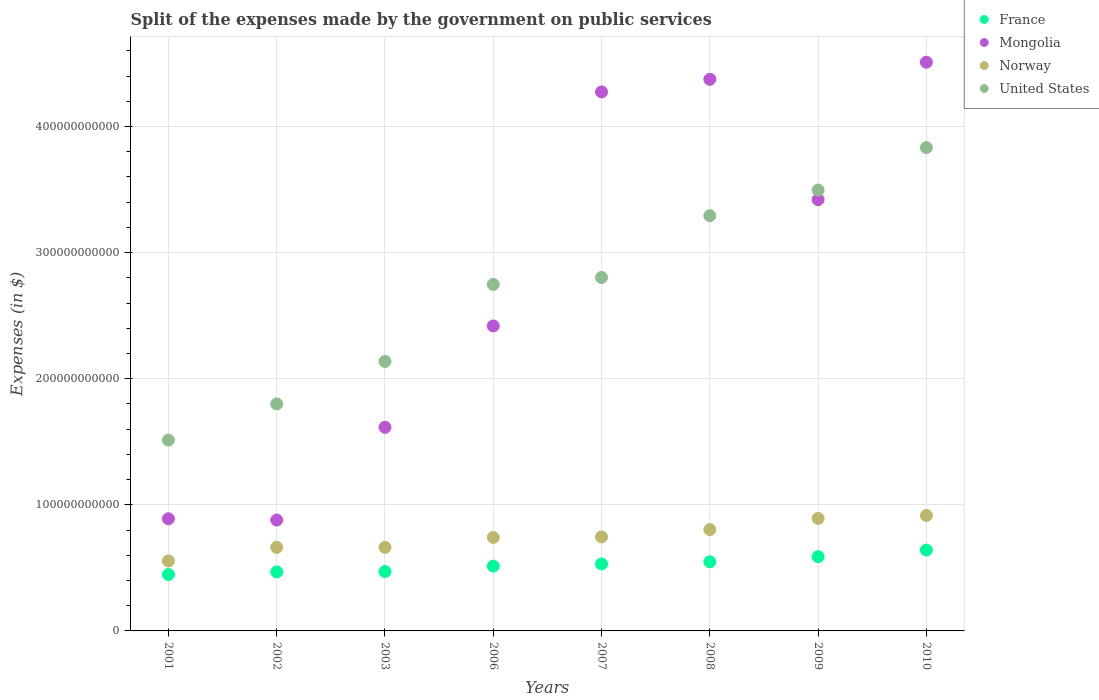What is the expenses made by the government on public services in France in 2007?
Ensure brevity in your answer.  5.31e+1. Across all years, what is the maximum expenses made by the government on public services in Norway?
Offer a very short reply. 9.15e+1. Across all years, what is the minimum expenses made by the government on public services in Norway?
Keep it short and to the point. 5.55e+1. In which year was the expenses made by the government on public services in Norway maximum?
Keep it short and to the point. 2010. What is the total expenses made by the government on public services in Mongolia in the graph?
Keep it short and to the point. 2.24e+12. What is the difference between the expenses made by the government on public services in France in 2008 and that in 2010?
Ensure brevity in your answer.  -9.30e+09. What is the difference between the expenses made by the government on public services in France in 2010 and the expenses made by the government on public services in Norway in 2009?
Keep it short and to the point. -2.51e+1. What is the average expenses made by the government on public services in France per year?
Make the answer very short. 5.26e+1. In the year 2010, what is the difference between the expenses made by the government on public services in Norway and expenses made by the government on public services in France?
Provide a succinct answer. 2.74e+1. What is the ratio of the expenses made by the government on public services in United States in 2006 to that in 2009?
Provide a succinct answer. 0.79. Is the difference between the expenses made by the government on public services in Norway in 2003 and 2007 greater than the difference between the expenses made by the government on public services in France in 2003 and 2007?
Your answer should be compact. No. What is the difference between the highest and the second highest expenses made by the government on public services in Mongolia?
Provide a short and direct response. 1.36e+1. What is the difference between the highest and the lowest expenses made by the government on public services in France?
Provide a short and direct response. 1.94e+1. Is the sum of the expenses made by the government on public services in France in 2006 and 2007 greater than the maximum expenses made by the government on public services in Norway across all years?
Keep it short and to the point. Yes. Does the expenses made by the government on public services in United States monotonically increase over the years?
Provide a succinct answer. Yes. Is the expenses made by the government on public services in Mongolia strictly less than the expenses made by the government on public services in France over the years?
Keep it short and to the point. No. How many dotlines are there?
Give a very brief answer. 4. What is the difference between two consecutive major ticks on the Y-axis?
Offer a very short reply. 1.00e+11. Does the graph contain any zero values?
Ensure brevity in your answer.  No. Does the graph contain grids?
Your response must be concise. Yes. Where does the legend appear in the graph?
Keep it short and to the point. Top right. How many legend labels are there?
Your answer should be very brief. 4. What is the title of the graph?
Your answer should be very brief. Split of the expenses made by the government on public services. Does "Zimbabwe" appear as one of the legend labels in the graph?
Your response must be concise. No. What is the label or title of the Y-axis?
Provide a short and direct response. Expenses (in $). What is the Expenses (in $) of France in 2001?
Make the answer very short. 4.47e+1. What is the Expenses (in $) in Mongolia in 2001?
Give a very brief answer. 8.89e+1. What is the Expenses (in $) of Norway in 2001?
Keep it short and to the point. 5.55e+1. What is the Expenses (in $) in United States in 2001?
Your answer should be compact. 1.51e+11. What is the Expenses (in $) in France in 2002?
Give a very brief answer. 4.68e+1. What is the Expenses (in $) in Mongolia in 2002?
Keep it short and to the point. 8.79e+1. What is the Expenses (in $) of Norway in 2002?
Make the answer very short. 6.63e+1. What is the Expenses (in $) in United States in 2002?
Provide a short and direct response. 1.80e+11. What is the Expenses (in $) in France in 2003?
Give a very brief answer. 4.71e+1. What is the Expenses (in $) in Mongolia in 2003?
Your answer should be very brief. 1.61e+11. What is the Expenses (in $) of Norway in 2003?
Your answer should be very brief. 6.63e+1. What is the Expenses (in $) in United States in 2003?
Your answer should be compact. 2.14e+11. What is the Expenses (in $) in France in 2006?
Keep it short and to the point. 5.14e+1. What is the Expenses (in $) in Mongolia in 2006?
Provide a short and direct response. 2.42e+11. What is the Expenses (in $) in Norway in 2006?
Offer a very short reply. 7.42e+1. What is the Expenses (in $) in United States in 2006?
Make the answer very short. 2.75e+11. What is the Expenses (in $) of France in 2007?
Your answer should be compact. 5.31e+1. What is the Expenses (in $) in Mongolia in 2007?
Ensure brevity in your answer.  4.27e+11. What is the Expenses (in $) of Norway in 2007?
Your answer should be very brief. 7.46e+1. What is the Expenses (in $) in United States in 2007?
Provide a short and direct response. 2.80e+11. What is the Expenses (in $) of France in 2008?
Your answer should be very brief. 5.48e+1. What is the Expenses (in $) of Mongolia in 2008?
Give a very brief answer. 4.37e+11. What is the Expenses (in $) in Norway in 2008?
Provide a short and direct response. 8.04e+1. What is the Expenses (in $) of United States in 2008?
Your answer should be very brief. 3.29e+11. What is the Expenses (in $) in France in 2009?
Your answer should be very brief. 5.89e+1. What is the Expenses (in $) of Mongolia in 2009?
Keep it short and to the point. 3.42e+11. What is the Expenses (in $) in Norway in 2009?
Offer a terse response. 8.92e+1. What is the Expenses (in $) in United States in 2009?
Provide a succinct answer. 3.50e+11. What is the Expenses (in $) in France in 2010?
Make the answer very short. 6.41e+1. What is the Expenses (in $) of Mongolia in 2010?
Keep it short and to the point. 4.51e+11. What is the Expenses (in $) in Norway in 2010?
Provide a succinct answer. 9.15e+1. What is the Expenses (in $) of United States in 2010?
Offer a very short reply. 3.83e+11. Across all years, what is the maximum Expenses (in $) in France?
Your response must be concise. 6.41e+1. Across all years, what is the maximum Expenses (in $) of Mongolia?
Keep it short and to the point. 4.51e+11. Across all years, what is the maximum Expenses (in $) in Norway?
Offer a very short reply. 9.15e+1. Across all years, what is the maximum Expenses (in $) of United States?
Provide a short and direct response. 3.83e+11. Across all years, what is the minimum Expenses (in $) of France?
Offer a terse response. 4.47e+1. Across all years, what is the minimum Expenses (in $) of Mongolia?
Offer a very short reply. 8.79e+1. Across all years, what is the minimum Expenses (in $) of Norway?
Your answer should be compact. 5.55e+1. Across all years, what is the minimum Expenses (in $) in United States?
Your answer should be very brief. 1.51e+11. What is the total Expenses (in $) in France in the graph?
Your answer should be compact. 4.21e+11. What is the total Expenses (in $) of Mongolia in the graph?
Your answer should be compact. 2.24e+12. What is the total Expenses (in $) of Norway in the graph?
Your response must be concise. 5.98e+11. What is the total Expenses (in $) in United States in the graph?
Keep it short and to the point. 2.16e+12. What is the difference between the Expenses (in $) of France in 2001 and that in 2002?
Give a very brief answer. -2.07e+09. What is the difference between the Expenses (in $) of Mongolia in 2001 and that in 2002?
Offer a very short reply. 1.00e+09. What is the difference between the Expenses (in $) in Norway in 2001 and that in 2002?
Your response must be concise. -1.07e+1. What is the difference between the Expenses (in $) of United States in 2001 and that in 2002?
Keep it short and to the point. -2.87e+1. What is the difference between the Expenses (in $) of France in 2001 and that in 2003?
Your response must be concise. -2.36e+09. What is the difference between the Expenses (in $) of Mongolia in 2001 and that in 2003?
Make the answer very short. -7.25e+1. What is the difference between the Expenses (in $) of Norway in 2001 and that in 2003?
Your response must be concise. -1.08e+1. What is the difference between the Expenses (in $) in United States in 2001 and that in 2003?
Make the answer very short. -6.24e+1. What is the difference between the Expenses (in $) of France in 2001 and that in 2006?
Offer a terse response. -6.65e+09. What is the difference between the Expenses (in $) in Mongolia in 2001 and that in 2006?
Offer a very short reply. -1.53e+11. What is the difference between the Expenses (in $) of Norway in 2001 and that in 2006?
Make the answer very short. -1.86e+1. What is the difference between the Expenses (in $) in United States in 2001 and that in 2006?
Give a very brief answer. -1.24e+11. What is the difference between the Expenses (in $) in France in 2001 and that in 2007?
Offer a very short reply. -8.38e+09. What is the difference between the Expenses (in $) in Mongolia in 2001 and that in 2007?
Provide a succinct answer. -3.39e+11. What is the difference between the Expenses (in $) of Norway in 2001 and that in 2007?
Your answer should be compact. -1.91e+1. What is the difference between the Expenses (in $) of United States in 2001 and that in 2007?
Give a very brief answer. -1.29e+11. What is the difference between the Expenses (in $) in France in 2001 and that in 2008?
Keep it short and to the point. -1.01e+1. What is the difference between the Expenses (in $) of Mongolia in 2001 and that in 2008?
Your response must be concise. -3.49e+11. What is the difference between the Expenses (in $) in Norway in 2001 and that in 2008?
Ensure brevity in your answer.  -2.49e+1. What is the difference between the Expenses (in $) of United States in 2001 and that in 2008?
Provide a succinct answer. -1.78e+11. What is the difference between the Expenses (in $) in France in 2001 and that in 2009?
Offer a terse response. -1.42e+1. What is the difference between the Expenses (in $) of Mongolia in 2001 and that in 2009?
Offer a terse response. -2.53e+11. What is the difference between the Expenses (in $) in Norway in 2001 and that in 2009?
Offer a terse response. -3.37e+1. What is the difference between the Expenses (in $) of United States in 2001 and that in 2009?
Offer a very short reply. -1.98e+11. What is the difference between the Expenses (in $) in France in 2001 and that in 2010?
Offer a terse response. -1.94e+1. What is the difference between the Expenses (in $) in Mongolia in 2001 and that in 2010?
Your answer should be very brief. -3.62e+11. What is the difference between the Expenses (in $) in Norway in 2001 and that in 2010?
Keep it short and to the point. -3.60e+1. What is the difference between the Expenses (in $) of United States in 2001 and that in 2010?
Keep it short and to the point. -2.32e+11. What is the difference between the Expenses (in $) of France in 2002 and that in 2003?
Provide a short and direct response. -2.92e+08. What is the difference between the Expenses (in $) of Mongolia in 2002 and that in 2003?
Your response must be concise. -7.35e+1. What is the difference between the Expenses (in $) of Norway in 2002 and that in 2003?
Provide a short and direct response. -7.00e+06. What is the difference between the Expenses (in $) of United States in 2002 and that in 2003?
Offer a very short reply. -3.37e+1. What is the difference between the Expenses (in $) in France in 2002 and that in 2006?
Offer a very short reply. -4.58e+09. What is the difference between the Expenses (in $) of Mongolia in 2002 and that in 2006?
Provide a succinct answer. -1.54e+11. What is the difference between the Expenses (in $) of Norway in 2002 and that in 2006?
Keep it short and to the point. -7.89e+09. What is the difference between the Expenses (in $) of United States in 2002 and that in 2006?
Your response must be concise. -9.48e+1. What is the difference between the Expenses (in $) of France in 2002 and that in 2007?
Your answer should be compact. -6.31e+09. What is the difference between the Expenses (in $) of Mongolia in 2002 and that in 2007?
Offer a very short reply. -3.40e+11. What is the difference between the Expenses (in $) in Norway in 2002 and that in 2007?
Make the answer very short. -8.31e+09. What is the difference between the Expenses (in $) in United States in 2002 and that in 2007?
Your answer should be very brief. -1.00e+11. What is the difference between the Expenses (in $) in France in 2002 and that in 2008?
Your response must be concise. -7.99e+09. What is the difference between the Expenses (in $) of Mongolia in 2002 and that in 2008?
Give a very brief answer. -3.50e+11. What is the difference between the Expenses (in $) of Norway in 2002 and that in 2008?
Provide a succinct answer. -1.41e+1. What is the difference between the Expenses (in $) of United States in 2002 and that in 2008?
Provide a short and direct response. -1.49e+11. What is the difference between the Expenses (in $) in France in 2002 and that in 2009?
Your answer should be very brief. -1.21e+1. What is the difference between the Expenses (in $) in Mongolia in 2002 and that in 2009?
Provide a succinct answer. -2.54e+11. What is the difference between the Expenses (in $) in Norway in 2002 and that in 2009?
Provide a succinct answer. -2.30e+1. What is the difference between the Expenses (in $) in United States in 2002 and that in 2009?
Make the answer very short. -1.70e+11. What is the difference between the Expenses (in $) of France in 2002 and that in 2010?
Offer a very short reply. -1.73e+1. What is the difference between the Expenses (in $) of Mongolia in 2002 and that in 2010?
Give a very brief answer. -3.63e+11. What is the difference between the Expenses (in $) of Norway in 2002 and that in 2010?
Keep it short and to the point. -2.53e+1. What is the difference between the Expenses (in $) of United States in 2002 and that in 2010?
Provide a short and direct response. -2.03e+11. What is the difference between the Expenses (in $) in France in 2003 and that in 2006?
Ensure brevity in your answer.  -4.28e+09. What is the difference between the Expenses (in $) in Mongolia in 2003 and that in 2006?
Offer a very short reply. -8.04e+1. What is the difference between the Expenses (in $) of Norway in 2003 and that in 2006?
Provide a short and direct response. -7.88e+09. What is the difference between the Expenses (in $) in United States in 2003 and that in 2006?
Your answer should be compact. -6.11e+1. What is the difference between the Expenses (in $) of France in 2003 and that in 2007?
Your response must be concise. -6.01e+09. What is the difference between the Expenses (in $) of Mongolia in 2003 and that in 2007?
Your response must be concise. -2.66e+11. What is the difference between the Expenses (in $) of Norway in 2003 and that in 2007?
Offer a very short reply. -8.30e+09. What is the difference between the Expenses (in $) in United States in 2003 and that in 2007?
Ensure brevity in your answer.  -6.66e+1. What is the difference between the Expenses (in $) in France in 2003 and that in 2008?
Provide a succinct answer. -7.69e+09. What is the difference between the Expenses (in $) in Mongolia in 2003 and that in 2008?
Your response must be concise. -2.76e+11. What is the difference between the Expenses (in $) in Norway in 2003 and that in 2008?
Ensure brevity in your answer.  -1.41e+1. What is the difference between the Expenses (in $) in United States in 2003 and that in 2008?
Make the answer very short. -1.16e+11. What is the difference between the Expenses (in $) of France in 2003 and that in 2009?
Make the answer very short. -1.18e+1. What is the difference between the Expenses (in $) in Mongolia in 2003 and that in 2009?
Give a very brief answer. -1.81e+11. What is the difference between the Expenses (in $) in Norway in 2003 and that in 2009?
Provide a short and direct response. -2.30e+1. What is the difference between the Expenses (in $) in United States in 2003 and that in 2009?
Your answer should be compact. -1.36e+11. What is the difference between the Expenses (in $) in France in 2003 and that in 2010?
Make the answer very short. -1.70e+1. What is the difference between the Expenses (in $) in Mongolia in 2003 and that in 2010?
Your answer should be compact. -2.90e+11. What is the difference between the Expenses (in $) in Norway in 2003 and that in 2010?
Ensure brevity in your answer.  -2.53e+1. What is the difference between the Expenses (in $) in United States in 2003 and that in 2010?
Give a very brief answer. -1.70e+11. What is the difference between the Expenses (in $) in France in 2006 and that in 2007?
Your answer should be compact. -1.73e+09. What is the difference between the Expenses (in $) of Mongolia in 2006 and that in 2007?
Keep it short and to the point. -1.86e+11. What is the difference between the Expenses (in $) of Norway in 2006 and that in 2007?
Provide a short and direct response. -4.20e+08. What is the difference between the Expenses (in $) of United States in 2006 and that in 2007?
Give a very brief answer. -5.50e+09. What is the difference between the Expenses (in $) of France in 2006 and that in 2008?
Ensure brevity in your answer.  -3.41e+09. What is the difference between the Expenses (in $) in Mongolia in 2006 and that in 2008?
Provide a succinct answer. -1.96e+11. What is the difference between the Expenses (in $) in Norway in 2006 and that in 2008?
Offer a terse response. -6.23e+09. What is the difference between the Expenses (in $) of United States in 2006 and that in 2008?
Give a very brief answer. -5.45e+1. What is the difference between the Expenses (in $) in France in 2006 and that in 2009?
Offer a very short reply. -7.52e+09. What is the difference between the Expenses (in $) of Mongolia in 2006 and that in 2009?
Offer a very short reply. -1.00e+11. What is the difference between the Expenses (in $) in Norway in 2006 and that in 2009?
Your answer should be compact. -1.51e+1. What is the difference between the Expenses (in $) of United States in 2006 and that in 2009?
Ensure brevity in your answer.  -7.48e+1. What is the difference between the Expenses (in $) in France in 2006 and that in 2010?
Your response must be concise. -1.27e+1. What is the difference between the Expenses (in $) of Mongolia in 2006 and that in 2010?
Your answer should be compact. -2.09e+11. What is the difference between the Expenses (in $) of Norway in 2006 and that in 2010?
Ensure brevity in your answer.  -1.74e+1. What is the difference between the Expenses (in $) in United States in 2006 and that in 2010?
Offer a very short reply. -1.08e+11. What is the difference between the Expenses (in $) in France in 2007 and that in 2008?
Provide a short and direct response. -1.68e+09. What is the difference between the Expenses (in $) of Mongolia in 2007 and that in 2008?
Give a very brief answer. -9.99e+09. What is the difference between the Expenses (in $) in Norway in 2007 and that in 2008?
Your answer should be compact. -5.81e+09. What is the difference between the Expenses (in $) in United States in 2007 and that in 2008?
Ensure brevity in your answer.  -4.90e+1. What is the difference between the Expenses (in $) of France in 2007 and that in 2009?
Make the answer very short. -5.79e+09. What is the difference between the Expenses (in $) of Mongolia in 2007 and that in 2009?
Your answer should be very brief. 8.54e+1. What is the difference between the Expenses (in $) of Norway in 2007 and that in 2009?
Your answer should be compact. -1.47e+1. What is the difference between the Expenses (in $) of United States in 2007 and that in 2009?
Keep it short and to the point. -6.93e+1. What is the difference between the Expenses (in $) in France in 2007 and that in 2010?
Give a very brief answer. -1.10e+1. What is the difference between the Expenses (in $) in Mongolia in 2007 and that in 2010?
Provide a short and direct response. -2.36e+1. What is the difference between the Expenses (in $) of Norway in 2007 and that in 2010?
Provide a short and direct response. -1.70e+1. What is the difference between the Expenses (in $) in United States in 2007 and that in 2010?
Keep it short and to the point. -1.03e+11. What is the difference between the Expenses (in $) in France in 2008 and that in 2009?
Provide a succinct answer. -4.11e+09. What is the difference between the Expenses (in $) in Mongolia in 2008 and that in 2009?
Offer a very short reply. 9.54e+1. What is the difference between the Expenses (in $) of Norway in 2008 and that in 2009?
Keep it short and to the point. -8.85e+09. What is the difference between the Expenses (in $) in United States in 2008 and that in 2009?
Provide a succinct answer. -2.03e+1. What is the difference between the Expenses (in $) in France in 2008 and that in 2010?
Your answer should be compact. -9.30e+09. What is the difference between the Expenses (in $) of Mongolia in 2008 and that in 2010?
Your answer should be compact. -1.36e+1. What is the difference between the Expenses (in $) in Norway in 2008 and that in 2010?
Provide a short and direct response. -1.11e+1. What is the difference between the Expenses (in $) in United States in 2008 and that in 2010?
Offer a terse response. -5.40e+1. What is the difference between the Expenses (in $) in France in 2009 and that in 2010?
Your response must be concise. -5.20e+09. What is the difference between the Expenses (in $) of Mongolia in 2009 and that in 2010?
Offer a very short reply. -1.09e+11. What is the difference between the Expenses (in $) in Norway in 2009 and that in 2010?
Your answer should be very brief. -2.29e+09. What is the difference between the Expenses (in $) in United States in 2009 and that in 2010?
Provide a succinct answer. -3.37e+1. What is the difference between the Expenses (in $) of France in 2001 and the Expenses (in $) of Mongolia in 2002?
Provide a short and direct response. -4.32e+1. What is the difference between the Expenses (in $) of France in 2001 and the Expenses (in $) of Norway in 2002?
Ensure brevity in your answer.  -2.15e+1. What is the difference between the Expenses (in $) in France in 2001 and the Expenses (in $) in United States in 2002?
Make the answer very short. -1.35e+11. What is the difference between the Expenses (in $) of Mongolia in 2001 and the Expenses (in $) of Norway in 2002?
Keep it short and to the point. 2.27e+1. What is the difference between the Expenses (in $) of Mongolia in 2001 and the Expenses (in $) of United States in 2002?
Your response must be concise. -9.11e+1. What is the difference between the Expenses (in $) of Norway in 2001 and the Expenses (in $) of United States in 2002?
Your answer should be very brief. -1.24e+11. What is the difference between the Expenses (in $) in France in 2001 and the Expenses (in $) in Mongolia in 2003?
Provide a succinct answer. -1.17e+11. What is the difference between the Expenses (in $) of France in 2001 and the Expenses (in $) of Norway in 2003?
Provide a short and direct response. -2.15e+1. What is the difference between the Expenses (in $) in France in 2001 and the Expenses (in $) in United States in 2003?
Offer a terse response. -1.69e+11. What is the difference between the Expenses (in $) in Mongolia in 2001 and the Expenses (in $) in Norway in 2003?
Keep it short and to the point. 2.27e+1. What is the difference between the Expenses (in $) of Mongolia in 2001 and the Expenses (in $) of United States in 2003?
Give a very brief answer. -1.25e+11. What is the difference between the Expenses (in $) in Norway in 2001 and the Expenses (in $) in United States in 2003?
Your answer should be very brief. -1.58e+11. What is the difference between the Expenses (in $) in France in 2001 and the Expenses (in $) in Mongolia in 2006?
Offer a terse response. -1.97e+11. What is the difference between the Expenses (in $) of France in 2001 and the Expenses (in $) of Norway in 2006?
Your answer should be compact. -2.94e+1. What is the difference between the Expenses (in $) in France in 2001 and the Expenses (in $) in United States in 2006?
Your answer should be compact. -2.30e+11. What is the difference between the Expenses (in $) of Mongolia in 2001 and the Expenses (in $) of Norway in 2006?
Offer a very short reply. 1.48e+1. What is the difference between the Expenses (in $) in Mongolia in 2001 and the Expenses (in $) in United States in 2006?
Your answer should be compact. -1.86e+11. What is the difference between the Expenses (in $) in Norway in 2001 and the Expenses (in $) in United States in 2006?
Your answer should be compact. -2.19e+11. What is the difference between the Expenses (in $) of France in 2001 and the Expenses (in $) of Mongolia in 2007?
Your response must be concise. -3.83e+11. What is the difference between the Expenses (in $) in France in 2001 and the Expenses (in $) in Norway in 2007?
Keep it short and to the point. -2.98e+1. What is the difference between the Expenses (in $) in France in 2001 and the Expenses (in $) in United States in 2007?
Give a very brief answer. -2.36e+11. What is the difference between the Expenses (in $) in Mongolia in 2001 and the Expenses (in $) in Norway in 2007?
Give a very brief answer. 1.44e+1. What is the difference between the Expenses (in $) of Mongolia in 2001 and the Expenses (in $) of United States in 2007?
Offer a very short reply. -1.91e+11. What is the difference between the Expenses (in $) in Norway in 2001 and the Expenses (in $) in United States in 2007?
Provide a short and direct response. -2.25e+11. What is the difference between the Expenses (in $) in France in 2001 and the Expenses (in $) in Mongolia in 2008?
Provide a succinct answer. -3.93e+11. What is the difference between the Expenses (in $) of France in 2001 and the Expenses (in $) of Norway in 2008?
Keep it short and to the point. -3.56e+1. What is the difference between the Expenses (in $) of France in 2001 and the Expenses (in $) of United States in 2008?
Ensure brevity in your answer.  -2.85e+11. What is the difference between the Expenses (in $) of Mongolia in 2001 and the Expenses (in $) of Norway in 2008?
Offer a very short reply. 8.55e+09. What is the difference between the Expenses (in $) of Mongolia in 2001 and the Expenses (in $) of United States in 2008?
Ensure brevity in your answer.  -2.40e+11. What is the difference between the Expenses (in $) in Norway in 2001 and the Expenses (in $) in United States in 2008?
Ensure brevity in your answer.  -2.74e+11. What is the difference between the Expenses (in $) of France in 2001 and the Expenses (in $) of Mongolia in 2009?
Keep it short and to the point. -2.97e+11. What is the difference between the Expenses (in $) in France in 2001 and the Expenses (in $) in Norway in 2009?
Provide a succinct answer. -4.45e+1. What is the difference between the Expenses (in $) of France in 2001 and the Expenses (in $) of United States in 2009?
Your answer should be compact. -3.05e+11. What is the difference between the Expenses (in $) of Mongolia in 2001 and the Expenses (in $) of Norway in 2009?
Give a very brief answer. -2.96e+08. What is the difference between the Expenses (in $) in Mongolia in 2001 and the Expenses (in $) in United States in 2009?
Your answer should be compact. -2.61e+11. What is the difference between the Expenses (in $) in Norway in 2001 and the Expenses (in $) in United States in 2009?
Give a very brief answer. -2.94e+11. What is the difference between the Expenses (in $) in France in 2001 and the Expenses (in $) in Mongolia in 2010?
Give a very brief answer. -4.06e+11. What is the difference between the Expenses (in $) of France in 2001 and the Expenses (in $) of Norway in 2010?
Offer a very short reply. -4.68e+1. What is the difference between the Expenses (in $) in France in 2001 and the Expenses (in $) in United States in 2010?
Provide a succinct answer. -3.39e+11. What is the difference between the Expenses (in $) in Mongolia in 2001 and the Expenses (in $) in Norway in 2010?
Keep it short and to the point. -2.59e+09. What is the difference between the Expenses (in $) in Mongolia in 2001 and the Expenses (in $) in United States in 2010?
Give a very brief answer. -2.94e+11. What is the difference between the Expenses (in $) in Norway in 2001 and the Expenses (in $) in United States in 2010?
Keep it short and to the point. -3.28e+11. What is the difference between the Expenses (in $) in France in 2002 and the Expenses (in $) in Mongolia in 2003?
Offer a terse response. -1.15e+11. What is the difference between the Expenses (in $) of France in 2002 and the Expenses (in $) of Norway in 2003?
Offer a terse response. -1.95e+1. What is the difference between the Expenses (in $) of France in 2002 and the Expenses (in $) of United States in 2003?
Make the answer very short. -1.67e+11. What is the difference between the Expenses (in $) in Mongolia in 2002 and the Expenses (in $) in Norway in 2003?
Your answer should be compact. 2.17e+1. What is the difference between the Expenses (in $) of Mongolia in 2002 and the Expenses (in $) of United States in 2003?
Your answer should be compact. -1.26e+11. What is the difference between the Expenses (in $) in Norway in 2002 and the Expenses (in $) in United States in 2003?
Provide a succinct answer. -1.47e+11. What is the difference between the Expenses (in $) of France in 2002 and the Expenses (in $) of Mongolia in 2006?
Your answer should be very brief. -1.95e+11. What is the difference between the Expenses (in $) of France in 2002 and the Expenses (in $) of Norway in 2006?
Provide a succinct answer. -2.73e+1. What is the difference between the Expenses (in $) of France in 2002 and the Expenses (in $) of United States in 2006?
Your response must be concise. -2.28e+11. What is the difference between the Expenses (in $) in Mongolia in 2002 and the Expenses (in $) in Norway in 2006?
Your response must be concise. 1.38e+1. What is the difference between the Expenses (in $) of Mongolia in 2002 and the Expenses (in $) of United States in 2006?
Provide a short and direct response. -1.87e+11. What is the difference between the Expenses (in $) in Norway in 2002 and the Expenses (in $) in United States in 2006?
Your answer should be very brief. -2.09e+11. What is the difference between the Expenses (in $) of France in 2002 and the Expenses (in $) of Mongolia in 2007?
Ensure brevity in your answer.  -3.81e+11. What is the difference between the Expenses (in $) of France in 2002 and the Expenses (in $) of Norway in 2007?
Offer a very short reply. -2.78e+1. What is the difference between the Expenses (in $) of France in 2002 and the Expenses (in $) of United States in 2007?
Your response must be concise. -2.33e+11. What is the difference between the Expenses (in $) in Mongolia in 2002 and the Expenses (in $) in Norway in 2007?
Make the answer very short. 1.34e+1. What is the difference between the Expenses (in $) of Mongolia in 2002 and the Expenses (in $) of United States in 2007?
Your answer should be very brief. -1.92e+11. What is the difference between the Expenses (in $) of Norway in 2002 and the Expenses (in $) of United States in 2007?
Offer a terse response. -2.14e+11. What is the difference between the Expenses (in $) in France in 2002 and the Expenses (in $) in Mongolia in 2008?
Your response must be concise. -3.91e+11. What is the difference between the Expenses (in $) in France in 2002 and the Expenses (in $) in Norway in 2008?
Provide a succinct answer. -3.36e+1. What is the difference between the Expenses (in $) of France in 2002 and the Expenses (in $) of United States in 2008?
Provide a succinct answer. -2.82e+11. What is the difference between the Expenses (in $) of Mongolia in 2002 and the Expenses (in $) of Norway in 2008?
Your answer should be compact. 7.55e+09. What is the difference between the Expenses (in $) in Mongolia in 2002 and the Expenses (in $) in United States in 2008?
Your answer should be compact. -2.41e+11. What is the difference between the Expenses (in $) of Norway in 2002 and the Expenses (in $) of United States in 2008?
Your answer should be compact. -2.63e+11. What is the difference between the Expenses (in $) of France in 2002 and the Expenses (in $) of Mongolia in 2009?
Give a very brief answer. -2.95e+11. What is the difference between the Expenses (in $) in France in 2002 and the Expenses (in $) in Norway in 2009?
Your response must be concise. -4.24e+1. What is the difference between the Expenses (in $) of France in 2002 and the Expenses (in $) of United States in 2009?
Keep it short and to the point. -3.03e+11. What is the difference between the Expenses (in $) of Mongolia in 2002 and the Expenses (in $) of Norway in 2009?
Make the answer very short. -1.30e+09. What is the difference between the Expenses (in $) in Mongolia in 2002 and the Expenses (in $) in United States in 2009?
Provide a short and direct response. -2.62e+11. What is the difference between the Expenses (in $) of Norway in 2002 and the Expenses (in $) of United States in 2009?
Your response must be concise. -2.83e+11. What is the difference between the Expenses (in $) in France in 2002 and the Expenses (in $) in Mongolia in 2010?
Offer a very short reply. -4.04e+11. What is the difference between the Expenses (in $) in France in 2002 and the Expenses (in $) in Norway in 2010?
Make the answer very short. -4.47e+1. What is the difference between the Expenses (in $) in France in 2002 and the Expenses (in $) in United States in 2010?
Your answer should be very brief. -3.36e+11. What is the difference between the Expenses (in $) in Mongolia in 2002 and the Expenses (in $) in Norway in 2010?
Ensure brevity in your answer.  -3.59e+09. What is the difference between the Expenses (in $) in Mongolia in 2002 and the Expenses (in $) in United States in 2010?
Offer a terse response. -2.95e+11. What is the difference between the Expenses (in $) in Norway in 2002 and the Expenses (in $) in United States in 2010?
Keep it short and to the point. -3.17e+11. What is the difference between the Expenses (in $) in France in 2003 and the Expenses (in $) in Mongolia in 2006?
Your answer should be compact. -1.95e+11. What is the difference between the Expenses (in $) in France in 2003 and the Expenses (in $) in Norway in 2006?
Your response must be concise. -2.70e+1. What is the difference between the Expenses (in $) in France in 2003 and the Expenses (in $) in United States in 2006?
Keep it short and to the point. -2.28e+11. What is the difference between the Expenses (in $) of Mongolia in 2003 and the Expenses (in $) of Norway in 2006?
Your answer should be compact. 8.73e+1. What is the difference between the Expenses (in $) of Mongolia in 2003 and the Expenses (in $) of United States in 2006?
Your answer should be compact. -1.13e+11. What is the difference between the Expenses (in $) of Norway in 2003 and the Expenses (in $) of United States in 2006?
Keep it short and to the point. -2.09e+11. What is the difference between the Expenses (in $) of France in 2003 and the Expenses (in $) of Mongolia in 2007?
Offer a very short reply. -3.80e+11. What is the difference between the Expenses (in $) of France in 2003 and the Expenses (in $) of Norway in 2007?
Make the answer very short. -2.75e+1. What is the difference between the Expenses (in $) of France in 2003 and the Expenses (in $) of United States in 2007?
Ensure brevity in your answer.  -2.33e+11. What is the difference between the Expenses (in $) of Mongolia in 2003 and the Expenses (in $) of Norway in 2007?
Offer a very short reply. 8.69e+1. What is the difference between the Expenses (in $) of Mongolia in 2003 and the Expenses (in $) of United States in 2007?
Provide a short and direct response. -1.19e+11. What is the difference between the Expenses (in $) in Norway in 2003 and the Expenses (in $) in United States in 2007?
Make the answer very short. -2.14e+11. What is the difference between the Expenses (in $) in France in 2003 and the Expenses (in $) in Mongolia in 2008?
Your answer should be compact. -3.90e+11. What is the difference between the Expenses (in $) of France in 2003 and the Expenses (in $) of Norway in 2008?
Give a very brief answer. -3.33e+1. What is the difference between the Expenses (in $) of France in 2003 and the Expenses (in $) of United States in 2008?
Ensure brevity in your answer.  -2.82e+11. What is the difference between the Expenses (in $) of Mongolia in 2003 and the Expenses (in $) of Norway in 2008?
Provide a succinct answer. 8.11e+1. What is the difference between the Expenses (in $) of Mongolia in 2003 and the Expenses (in $) of United States in 2008?
Give a very brief answer. -1.68e+11. What is the difference between the Expenses (in $) of Norway in 2003 and the Expenses (in $) of United States in 2008?
Offer a terse response. -2.63e+11. What is the difference between the Expenses (in $) in France in 2003 and the Expenses (in $) in Mongolia in 2009?
Your response must be concise. -2.95e+11. What is the difference between the Expenses (in $) of France in 2003 and the Expenses (in $) of Norway in 2009?
Keep it short and to the point. -4.21e+1. What is the difference between the Expenses (in $) in France in 2003 and the Expenses (in $) in United States in 2009?
Your response must be concise. -3.02e+11. What is the difference between the Expenses (in $) in Mongolia in 2003 and the Expenses (in $) in Norway in 2009?
Keep it short and to the point. 7.22e+1. What is the difference between the Expenses (in $) of Mongolia in 2003 and the Expenses (in $) of United States in 2009?
Offer a terse response. -1.88e+11. What is the difference between the Expenses (in $) of Norway in 2003 and the Expenses (in $) of United States in 2009?
Provide a short and direct response. -2.83e+11. What is the difference between the Expenses (in $) of France in 2003 and the Expenses (in $) of Mongolia in 2010?
Your response must be concise. -4.04e+11. What is the difference between the Expenses (in $) of France in 2003 and the Expenses (in $) of Norway in 2010?
Offer a terse response. -4.44e+1. What is the difference between the Expenses (in $) of France in 2003 and the Expenses (in $) of United States in 2010?
Give a very brief answer. -3.36e+11. What is the difference between the Expenses (in $) in Mongolia in 2003 and the Expenses (in $) in Norway in 2010?
Your answer should be very brief. 6.99e+1. What is the difference between the Expenses (in $) of Mongolia in 2003 and the Expenses (in $) of United States in 2010?
Make the answer very short. -2.22e+11. What is the difference between the Expenses (in $) in Norway in 2003 and the Expenses (in $) in United States in 2010?
Your answer should be compact. -3.17e+11. What is the difference between the Expenses (in $) in France in 2006 and the Expenses (in $) in Mongolia in 2007?
Ensure brevity in your answer.  -3.76e+11. What is the difference between the Expenses (in $) of France in 2006 and the Expenses (in $) of Norway in 2007?
Make the answer very short. -2.32e+1. What is the difference between the Expenses (in $) in France in 2006 and the Expenses (in $) in United States in 2007?
Make the answer very short. -2.29e+11. What is the difference between the Expenses (in $) in Mongolia in 2006 and the Expenses (in $) in Norway in 2007?
Offer a terse response. 1.67e+11. What is the difference between the Expenses (in $) in Mongolia in 2006 and the Expenses (in $) in United States in 2007?
Keep it short and to the point. -3.84e+1. What is the difference between the Expenses (in $) in Norway in 2006 and the Expenses (in $) in United States in 2007?
Provide a succinct answer. -2.06e+11. What is the difference between the Expenses (in $) in France in 2006 and the Expenses (in $) in Mongolia in 2008?
Your answer should be compact. -3.86e+11. What is the difference between the Expenses (in $) of France in 2006 and the Expenses (in $) of Norway in 2008?
Provide a succinct answer. -2.90e+1. What is the difference between the Expenses (in $) of France in 2006 and the Expenses (in $) of United States in 2008?
Offer a very short reply. -2.78e+11. What is the difference between the Expenses (in $) of Mongolia in 2006 and the Expenses (in $) of Norway in 2008?
Offer a very short reply. 1.61e+11. What is the difference between the Expenses (in $) in Mongolia in 2006 and the Expenses (in $) in United States in 2008?
Provide a succinct answer. -8.74e+1. What is the difference between the Expenses (in $) in Norway in 2006 and the Expenses (in $) in United States in 2008?
Offer a terse response. -2.55e+11. What is the difference between the Expenses (in $) in France in 2006 and the Expenses (in $) in Mongolia in 2009?
Provide a short and direct response. -2.91e+11. What is the difference between the Expenses (in $) in France in 2006 and the Expenses (in $) in Norway in 2009?
Provide a succinct answer. -3.78e+1. What is the difference between the Expenses (in $) of France in 2006 and the Expenses (in $) of United States in 2009?
Provide a short and direct response. -2.98e+11. What is the difference between the Expenses (in $) in Mongolia in 2006 and the Expenses (in $) in Norway in 2009?
Provide a short and direct response. 1.53e+11. What is the difference between the Expenses (in $) in Mongolia in 2006 and the Expenses (in $) in United States in 2009?
Offer a terse response. -1.08e+11. What is the difference between the Expenses (in $) of Norway in 2006 and the Expenses (in $) of United States in 2009?
Your response must be concise. -2.75e+11. What is the difference between the Expenses (in $) of France in 2006 and the Expenses (in $) of Mongolia in 2010?
Provide a succinct answer. -4.00e+11. What is the difference between the Expenses (in $) of France in 2006 and the Expenses (in $) of Norway in 2010?
Provide a short and direct response. -4.01e+1. What is the difference between the Expenses (in $) in France in 2006 and the Expenses (in $) in United States in 2010?
Keep it short and to the point. -3.32e+11. What is the difference between the Expenses (in $) of Mongolia in 2006 and the Expenses (in $) of Norway in 2010?
Give a very brief answer. 1.50e+11. What is the difference between the Expenses (in $) of Mongolia in 2006 and the Expenses (in $) of United States in 2010?
Your answer should be compact. -1.41e+11. What is the difference between the Expenses (in $) of Norway in 2006 and the Expenses (in $) of United States in 2010?
Make the answer very short. -3.09e+11. What is the difference between the Expenses (in $) of France in 2007 and the Expenses (in $) of Mongolia in 2008?
Offer a terse response. -3.84e+11. What is the difference between the Expenses (in $) in France in 2007 and the Expenses (in $) in Norway in 2008?
Keep it short and to the point. -2.73e+1. What is the difference between the Expenses (in $) of France in 2007 and the Expenses (in $) of United States in 2008?
Your answer should be very brief. -2.76e+11. What is the difference between the Expenses (in $) of Mongolia in 2007 and the Expenses (in $) of Norway in 2008?
Ensure brevity in your answer.  3.47e+11. What is the difference between the Expenses (in $) of Mongolia in 2007 and the Expenses (in $) of United States in 2008?
Ensure brevity in your answer.  9.82e+1. What is the difference between the Expenses (in $) of Norway in 2007 and the Expenses (in $) of United States in 2008?
Provide a succinct answer. -2.55e+11. What is the difference between the Expenses (in $) in France in 2007 and the Expenses (in $) in Mongolia in 2009?
Offer a very short reply. -2.89e+11. What is the difference between the Expenses (in $) of France in 2007 and the Expenses (in $) of Norway in 2009?
Offer a very short reply. -3.61e+1. What is the difference between the Expenses (in $) of France in 2007 and the Expenses (in $) of United States in 2009?
Provide a short and direct response. -2.96e+11. What is the difference between the Expenses (in $) of Mongolia in 2007 and the Expenses (in $) of Norway in 2009?
Provide a short and direct response. 3.38e+11. What is the difference between the Expenses (in $) in Mongolia in 2007 and the Expenses (in $) in United States in 2009?
Offer a terse response. 7.79e+1. What is the difference between the Expenses (in $) in Norway in 2007 and the Expenses (in $) in United States in 2009?
Your answer should be compact. -2.75e+11. What is the difference between the Expenses (in $) in France in 2007 and the Expenses (in $) in Mongolia in 2010?
Provide a short and direct response. -3.98e+11. What is the difference between the Expenses (in $) of France in 2007 and the Expenses (in $) of Norway in 2010?
Your answer should be very brief. -3.84e+1. What is the difference between the Expenses (in $) of France in 2007 and the Expenses (in $) of United States in 2010?
Ensure brevity in your answer.  -3.30e+11. What is the difference between the Expenses (in $) of Mongolia in 2007 and the Expenses (in $) of Norway in 2010?
Your answer should be compact. 3.36e+11. What is the difference between the Expenses (in $) in Mongolia in 2007 and the Expenses (in $) in United States in 2010?
Offer a very short reply. 4.42e+1. What is the difference between the Expenses (in $) of Norway in 2007 and the Expenses (in $) of United States in 2010?
Your answer should be very brief. -3.09e+11. What is the difference between the Expenses (in $) of France in 2008 and the Expenses (in $) of Mongolia in 2009?
Make the answer very short. -2.87e+11. What is the difference between the Expenses (in $) in France in 2008 and the Expenses (in $) in Norway in 2009?
Your answer should be compact. -3.44e+1. What is the difference between the Expenses (in $) in France in 2008 and the Expenses (in $) in United States in 2009?
Provide a succinct answer. -2.95e+11. What is the difference between the Expenses (in $) in Mongolia in 2008 and the Expenses (in $) in Norway in 2009?
Ensure brevity in your answer.  3.48e+11. What is the difference between the Expenses (in $) in Mongolia in 2008 and the Expenses (in $) in United States in 2009?
Your answer should be very brief. 8.79e+1. What is the difference between the Expenses (in $) of Norway in 2008 and the Expenses (in $) of United States in 2009?
Make the answer very short. -2.69e+11. What is the difference between the Expenses (in $) of France in 2008 and the Expenses (in $) of Mongolia in 2010?
Offer a terse response. -3.96e+11. What is the difference between the Expenses (in $) of France in 2008 and the Expenses (in $) of Norway in 2010?
Your response must be concise. -3.67e+1. What is the difference between the Expenses (in $) in France in 2008 and the Expenses (in $) in United States in 2010?
Offer a very short reply. -3.29e+11. What is the difference between the Expenses (in $) of Mongolia in 2008 and the Expenses (in $) of Norway in 2010?
Ensure brevity in your answer.  3.46e+11. What is the difference between the Expenses (in $) in Mongolia in 2008 and the Expenses (in $) in United States in 2010?
Keep it short and to the point. 5.42e+1. What is the difference between the Expenses (in $) in Norway in 2008 and the Expenses (in $) in United States in 2010?
Ensure brevity in your answer.  -3.03e+11. What is the difference between the Expenses (in $) of France in 2009 and the Expenses (in $) of Mongolia in 2010?
Make the answer very short. -3.92e+11. What is the difference between the Expenses (in $) of France in 2009 and the Expenses (in $) of Norway in 2010?
Give a very brief answer. -3.26e+1. What is the difference between the Expenses (in $) in France in 2009 and the Expenses (in $) in United States in 2010?
Make the answer very short. -3.24e+11. What is the difference between the Expenses (in $) of Mongolia in 2009 and the Expenses (in $) of Norway in 2010?
Make the answer very short. 2.51e+11. What is the difference between the Expenses (in $) of Mongolia in 2009 and the Expenses (in $) of United States in 2010?
Ensure brevity in your answer.  -4.13e+1. What is the difference between the Expenses (in $) in Norway in 2009 and the Expenses (in $) in United States in 2010?
Your answer should be very brief. -2.94e+11. What is the average Expenses (in $) in France per year?
Your answer should be compact. 5.26e+1. What is the average Expenses (in $) in Mongolia per year?
Your answer should be very brief. 2.80e+11. What is the average Expenses (in $) of Norway per year?
Provide a short and direct response. 7.47e+1. What is the average Expenses (in $) of United States per year?
Offer a very short reply. 2.70e+11. In the year 2001, what is the difference between the Expenses (in $) of France and Expenses (in $) of Mongolia?
Provide a short and direct response. -4.42e+1. In the year 2001, what is the difference between the Expenses (in $) in France and Expenses (in $) in Norway?
Your response must be concise. -1.08e+1. In the year 2001, what is the difference between the Expenses (in $) of France and Expenses (in $) of United States?
Offer a terse response. -1.07e+11. In the year 2001, what is the difference between the Expenses (in $) in Mongolia and Expenses (in $) in Norway?
Provide a succinct answer. 3.34e+1. In the year 2001, what is the difference between the Expenses (in $) of Mongolia and Expenses (in $) of United States?
Provide a succinct answer. -6.24e+1. In the year 2001, what is the difference between the Expenses (in $) in Norway and Expenses (in $) in United States?
Provide a succinct answer. -9.58e+1. In the year 2002, what is the difference between the Expenses (in $) of France and Expenses (in $) of Mongolia?
Your response must be concise. -4.11e+1. In the year 2002, what is the difference between the Expenses (in $) of France and Expenses (in $) of Norway?
Ensure brevity in your answer.  -1.94e+1. In the year 2002, what is the difference between the Expenses (in $) of France and Expenses (in $) of United States?
Your answer should be compact. -1.33e+11. In the year 2002, what is the difference between the Expenses (in $) in Mongolia and Expenses (in $) in Norway?
Keep it short and to the point. 2.17e+1. In the year 2002, what is the difference between the Expenses (in $) of Mongolia and Expenses (in $) of United States?
Provide a short and direct response. -9.21e+1. In the year 2002, what is the difference between the Expenses (in $) in Norway and Expenses (in $) in United States?
Your response must be concise. -1.14e+11. In the year 2003, what is the difference between the Expenses (in $) of France and Expenses (in $) of Mongolia?
Your response must be concise. -1.14e+11. In the year 2003, what is the difference between the Expenses (in $) of France and Expenses (in $) of Norway?
Keep it short and to the point. -1.92e+1. In the year 2003, what is the difference between the Expenses (in $) of France and Expenses (in $) of United States?
Make the answer very short. -1.67e+11. In the year 2003, what is the difference between the Expenses (in $) of Mongolia and Expenses (in $) of Norway?
Ensure brevity in your answer.  9.52e+1. In the year 2003, what is the difference between the Expenses (in $) of Mongolia and Expenses (in $) of United States?
Your response must be concise. -5.22e+1. In the year 2003, what is the difference between the Expenses (in $) in Norway and Expenses (in $) in United States?
Your answer should be very brief. -1.47e+11. In the year 2006, what is the difference between the Expenses (in $) in France and Expenses (in $) in Mongolia?
Keep it short and to the point. -1.90e+11. In the year 2006, what is the difference between the Expenses (in $) of France and Expenses (in $) of Norway?
Offer a very short reply. -2.28e+1. In the year 2006, what is the difference between the Expenses (in $) in France and Expenses (in $) in United States?
Make the answer very short. -2.23e+11. In the year 2006, what is the difference between the Expenses (in $) of Mongolia and Expenses (in $) of Norway?
Provide a short and direct response. 1.68e+11. In the year 2006, what is the difference between the Expenses (in $) of Mongolia and Expenses (in $) of United States?
Ensure brevity in your answer.  -3.29e+1. In the year 2006, what is the difference between the Expenses (in $) of Norway and Expenses (in $) of United States?
Make the answer very short. -2.01e+11. In the year 2007, what is the difference between the Expenses (in $) of France and Expenses (in $) of Mongolia?
Offer a very short reply. -3.74e+11. In the year 2007, what is the difference between the Expenses (in $) in France and Expenses (in $) in Norway?
Keep it short and to the point. -2.15e+1. In the year 2007, what is the difference between the Expenses (in $) in France and Expenses (in $) in United States?
Keep it short and to the point. -2.27e+11. In the year 2007, what is the difference between the Expenses (in $) of Mongolia and Expenses (in $) of Norway?
Offer a very short reply. 3.53e+11. In the year 2007, what is the difference between the Expenses (in $) of Mongolia and Expenses (in $) of United States?
Offer a terse response. 1.47e+11. In the year 2007, what is the difference between the Expenses (in $) of Norway and Expenses (in $) of United States?
Ensure brevity in your answer.  -2.06e+11. In the year 2008, what is the difference between the Expenses (in $) in France and Expenses (in $) in Mongolia?
Offer a terse response. -3.83e+11. In the year 2008, what is the difference between the Expenses (in $) of France and Expenses (in $) of Norway?
Provide a succinct answer. -2.56e+1. In the year 2008, what is the difference between the Expenses (in $) of France and Expenses (in $) of United States?
Give a very brief answer. -2.75e+11. In the year 2008, what is the difference between the Expenses (in $) in Mongolia and Expenses (in $) in Norway?
Your response must be concise. 3.57e+11. In the year 2008, what is the difference between the Expenses (in $) in Mongolia and Expenses (in $) in United States?
Make the answer very short. 1.08e+11. In the year 2008, what is the difference between the Expenses (in $) in Norway and Expenses (in $) in United States?
Provide a succinct answer. -2.49e+11. In the year 2009, what is the difference between the Expenses (in $) of France and Expenses (in $) of Mongolia?
Make the answer very short. -2.83e+11. In the year 2009, what is the difference between the Expenses (in $) of France and Expenses (in $) of Norway?
Your answer should be compact. -3.03e+1. In the year 2009, what is the difference between the Expenses (in $) in France and Expenses (in $) in United States?
Provide a short and direct response. -2.91e+11. In the year 2009, what is the difference between the Expenses (in $) in Mongolia and Expenses (in $) in Norway?
Give a very brief answer. 2.53e+11. In the year 2009, what is the difference between the Expenses (in $) of Mongolia and Expenses (in $) of United States?
Make the answer very short. -7.55e+09. In the year 2009, what is the difference between the Expenses (in $) of Norway and Expenses (in $) of United States?
Provide a short and direct response. -2.60e+11. In the year 2010, what is the difference between the Expenses (in $) in France and Expenses (in $) in Mongolia?
Make the answer very short. -3.87e+11. In the year 2010, what is the difference between the Expenses (in $) in France and Expenses (in $) in Norway?
Your answer should be very brief. -2.74e+1. In the year 2010, what is the difference between the Expenses (in $) of France and Expenses (in $) of United States?
Offer a very short reply. -3.19e+11. In the year 2010, what is the difference between the Expenses (in $) of Mongolia and Expenses (in $) of Norway?
Your answer should be very brief. 3.60e+11. In the year 2010, what is the difference between the Expenses (in $) of Mongolia and Expenses (in $) of United States?
Make the answer very short. 6.77e+1. In the year 2010, what is the difference between the Expenses (in $) in Norway and Expenses (in $) in United States?
Provide a succinct answer. -2.92e+11. What is the ratio of the Expenses (in $) in France in 2001 to that in 2002?
Your answer should be compact. 0.96. What is the ratio of the Expenses (in $) of Mongolia in 2001 to that in 2002?
Your response must be concise. 1.01. What is the ratio of the Expenses (in $) in Norway in 2001 to that in 2002?
Provide a short and direct response. 0.84. What is the ratio of the Expenses (in $) of United States in 2001 to that in 2002?
Your response must be concise. 0.84. What is the ratio of the Expenses (in $) of France in 2001 to that in 2003?
Provide a succinct answer. 0.95. What is the ratio of the Expenses (in $) in Mongolia in 2001 to that in 2003?
Provide a short and direct response. 0.55. What is the ratio of the Expenses (in $) of Norway in 2001 to that in 2003?
Your answer should be very brief. 0.84. What is the ratio of the Expenses (in $) of United States in 2001 to that in 2003?
Give a very brief answer. 0.71. What is the ratio of the Expenses (in $) of France in 2001 to that in 2006?
Give a very brief answer. 0.87. What is the ratio of the Expenses (in $) of Mongolia in 2001 to that in 2006?
Make the answer very short. 0.37. What is the ratio of the Expenses (in $) of Norway in 2001 to that in 2006?
Your answer should be compact. 0.75. What is the ratio of the Expenses (in $) of United States in 2001 to that in 2006?
Make the answer very short. 0.55. What is the ratio of the Expenses (in $) in France in 2001 to that in 2007?
Ensure brevity in your answer.  0.84. What is the ratio of the Expenses (in $) in Mongolia in 2001 to that in 2007?
Your answer should be very brief. 0.21. What is the ratio of the Expenses (in $) of Norway in 2001 to that in 2007?
Keep it short and to the point. 0.74. What is the ratio of the Expenses (in $) of United States in 2001 to that in 2007?
Keep it short and to the point. 0.54. What is the ratio of the Expenses (in $) of France in 2001 to that in 2008?
Offer a terse response. 0.82. What is the ratio of the Expenses (in $) of Mongolia in 2001 to that in 2008?
Your response must be concise. 0.2. What is the ratio of the Expenses (in $) in Norway in 2001 to that in 2008?
Keep it short and to the point. 0.69. What is the ratio of the Expenses (in $) in United States in 2001 to that in 2008?
Make the answer very short. 0.46. What is the ratio of the Expenses (in $) of France in 2001 to that in 2009?
Ensure brevity in your answer.  0.76. What is the ratio of the Expenses (in $) in Mongolia in 2001 to that in 2009?
Your answer should be very brief. 0.26. What is the ratio of the Expenses (in $) in Norway in 2001 to that in 2009?
Your answer should be very brief. 0.62. What is the ratio of the Expenses (in $) in United States in 2001 to that in 2009?
Your answer should be compact. 0.43. What is the ratio of the Expenses (in $) of France in 2001 to that in 2010?
Your response must be concise. 0.7. What is the ratio of the Expenses (in $) in Mongolia in 2001 to that in 2010?
Ensure brevity in your answer.  0.2. What is the ratio of the Expenses (in $) of Norway in 2001 to that in 2010?
Provide a short and direct response. 0.61. What is the ratio of the Expenses (in $) of United States in 2001 to that in 2010?
Offer a terse response. 0.39. What is the ratio of the Expenses (in $) of France in 2002 to that in 2003?
Your response must be concise. 0.99. What is the ratio of the Expenses (in $) of Mongolia in 2002 to that in 2003?
Provide a succinct answer. 0.54. What is the ratio of the Expenses (in $) in United States in 2002 to that in 2003?
Ensure brevity in your answer.  0.84. What is the ratio of the Expenses (in $) of France in 2002 to that in 2006?
Keep it short and to the point. 0.91. What is the ratio of the Expenses (in $) in Mongolia in 2002 to that in 2006?
Provide a succinct answer. 0.36. What is the ratio of the Expenses (in $) in Norway in 2002 to that in 2006?
Your answer should be compact. 0.89. What is the ratio of the Expenses (in $) in United States in 2002 to that in 2006?
Your response must be concise. 0.66. What is the ratio of the Expenses (in $) in France in 2002 to that in 2007?
Provide a short and direct response. 0.88. What is the ratio of the Expenses (in $) of Mongolia in 2002 to that in 2007?
Offer a terse response. 0.21. What is the ratio of the Expenses (in $) in Norway in 2002 to that in 2007?
Keep it short and to the point. 0.89. What is the ratio of the Expenses (in $) of United States in 2002 to that in 2007?
Your answer should be very brief. 0.64. What is the ratio of the Expenses (in $) in France in 2002 to that in 2008?
Provide a succinct answer. 0.85. What is the ratio of the Expenses (in $) in Mongolia in 2002 to that in 2008?
Provide a succinct answer. 0.2. What is the ratio of the Expenses (in $) of Norway in 2002 to that in 2008?
Ensure brevity in your answer.  0.82. What is the ratio of the Expenses (in $) of United States in 2002 to that in 2008?
Provide a short and direct response. 0.55. What is the ratio of the Expenses (in $) in France in 2002 to that in 2009?
Make the answer very short. 0.79. What is the ratio of the Expenses (in $) in Mongolia in 2002 to that in 2009?
Ensure brevity in your answer.  0.26. What is the ratio of the Expenses (in $) in Norway in 2002 to that in 2009?
Ensure brevity in your answer.  0.74. What is the ratio of the Expenses (in $) of United States in 2002 to that in 2009?
Provide a short and direct response. 0.51. What is the ratio of the Expenses (in $) in France in 2002 to that in 2010?
Your response must be concise. 0.73. What is the ratio of the Expenses (in $) of Mongolia in 2002 to that in 2010?
Your response must be concise. 0.2. What is the ratio of the Expenses (in $) in Norway in 2002 to that in 2010?
Offer a very short reply. 0.72. What is the ratio of the Expenses (in $) of United States in 2002 to that in 2010?
Keep it short and to the point. 0.47. What is the ratio of the Expenses (in $) of France in 2003 to that in 2006?
Ensure brevity in your answer.  0.92. What is the ratio of the Expenses (in $) of Mongolia in 2003 to that in 2006?
Keep it short and to the point. 0.67. What is the ratio of the Expenses (in $) of Norway in 2003 to that in 2006?
Keep it short and to the point. 0.89. What is the ratio of the Expenses (in $) of United States in 2003 to that in 2006?
Your answer should be very brief. 0.78. What is the ratio of the Expenses (in $) in France in 2003 to that in 2007?
Keep it short and to the point. 0.89. What is the ratio of the Expenses (in $) of Mongolia in 2003 to that in 2007?
Your response must be concise. 0.38. What is the ratio of the Expenses (in $) in Norway in 2003 to that in 2007?
Provide a short and direct response. 0.89. What is the ratio of the Expenses (in $) of United States in 2003 to that in 2007?
Offer a very short reply. 0.76. What is the ratio of the Expenses (in $) of France in 2003 to that in 2008?
Offer a very short reply. 0.86. What is the ratio of the Expenses (in $) of Mongolia in 2003 to that in 2008?
Offer a very short reply. 0.37. What is the ratio of the Expenses (in $) in Norway in 2003 to that in 2008?
Ensure brevity in your answer.  0.82. What is the ratio of the Expenses (in $) in United States in 2003 to that in 2008?
Your answer should be very brief. 0.65. What is the ratio of the Expenses (in $) in France in 2003 to that in 2009?
Offer a terse response. 0.8. What is the ratio of the Expenses (in $) in Mongolia in 2003 to that in 2009?
Your answer should be very brief. 0.47. What is the ratio of the Expenses (in $) in Norway in 2003 to that in 2009?
Provide a succinct answer. 0.74. What is the ratio of the Expenses (in $) of United States in 2003 to that in 2009?
Provide a short and direct response. 0.61. What is the ratio of the Expenses (in $) in France in 2003 to that in 2010?
Make the answer very short. 0.73. What is the ratio of the Expenses (in $) of Mongolia in 2003 to that in 2010?
Provide a succinct answer. 0.36. What is the ratio of the Expenses (in $) in Norway in 2003 to that in 2010?
Keep it short and to the point. 0.72. What is the ratio of the Expenses (in $) of United States in 2003 to that in 2010?
Keep it short and to the point. 0.56. What is the ratio of the Expenses (in $) in France in 2006 to that in 2007?
Your response must be concise. 0.97. What is the ratio of the Expenses (in $) in Mongolia in 2006 to that in 2007?
Offer a very short reply. 0.57. What is the ratio of the Expenses (in $) in Norway in 2006 to that in 2007?
Give a very brief answer. 0.99. What is the ratio of the Expenses (in $) of United States in 2006 to that in 2007?
Your answer should be compact. 0.98. What is the ratio of the Expenses (in $) of France in 2006 to that in 2008?
Your response must be concise. 0.94. What is the ratio of the Expenses (in $) in Mongolia in 2006 to that in 2008?
Keep it short and to the point. 0.55. What is the ratio of the Expenses (in $) in Norway in 2006 to that in 2008?
Offer a very short reply. 0.92. What is the ratio of the Expenses (in $) in United States in 2006 to that in 2008?
Provide a short and direct response. 0.83. What is the ratio of the Expenses (in $) in France in 2006 to that in 2009?
Provide a short and direct response. 0.87. What is the ratio of the Expenses (in $) of Mongolia in 2006 to that in 2009?
Your answer should be very brief. 0.71. What is the ratio of the Expenses (in $) in Norway in 2006 to that in 2009?
Your answer should be very brief. 0.83. What is the ratio of the Expenses (in $) of United States in 2006 to that in 2009?
Keep it short and to the point. 0.79. What is the ratio of the Expenses (in $) in France in 2006 to that in 2010?
Provide a short and direct response. 0.8. What is the ratio of the Expenses (in $) in Mongolia in 2006 to that in 2010?
Your answer should be very brief. 0.54. What is the ratio of the Expenses (in $) in Norway in 2006 to that in 2010?
Your answer should be very brief. 0.81. What is the ratio of the Expenses (in $) of United States in 2006 to that in 2010?
Offer a terse response. 0.72. What is the ratio of the Expenses (in $) in France in 2007 to that in 2008?
Provide a short and direct response. 0.97. What is the ratio of the Expenses (in $) of Mongolia in 2007 to that in 2008?
Make the answer very short. 0.98. What is the ratio of the Expenses (in $) in Norway in 2007 to that in 2008?
Your answer should be very brief. 0.93. What is the ratio of the Expenses (in $) in United States in 2007 to that in 2008?
Provide a short and direct response. 0.85. What is the ratio of the Expenses (in $) of France in 2007 to that in 2009?
Your response must be concise. 0.9. What is the ratio of the Expenses (in $) in Mongolia in 2007 to that in 2009?
Ensure brevity in your answer.  1.25. What is the ratio of the Expenses (in $) in Norway in 2007 to that in 2009?
Ensure brevity in your answer.  0.84. What is the ratio of the Expenses (in $) in United States in 2007 to that in 2009?
Offer a very short reply. 0.8. What is the ratio of the Expenses (in $) in France in 2007 to that in 2010?
Your answer should be compact. 0.83. What is the ratio of the Expenses (in $) in Mongolia in 2007 to that in 2010?
Offer a very short reply. 0.95. What is the ratio of the Expenses (in $) in Norway in 2007 to that in 2010?
Your answer should be compact. 0.81. What is the ratio of the Expenses (in $) in United States in 2007 to that in 2010?
Your response must be concise. 0.73. What is the ratio of the Expenses (in $) of France in 2008 to that in 2009?
Provide a short and direct response. 0.93. What is the ratio of the Expenses (in $) in Mongolia in 2008 to that in 2009?
Keep it short and to the point. 1.28. What is the ratio of the Expenses (in $) in Norway in 2008 to that in 2009?
Your answer should be compact. 0.9. What is the ratio of the Expenses (in $) in United States in 2008 to that in 2009?
Your answer should be very brief. 0.94. What is the ratio of the Expenses (in $) in France in 2008 to that in 2010?
Ensure brevity in your answer.  0.85. What is the ratio of the Expenses (in $) of Mongolia in 2008 to that in 2010?
Offer a terse response. 0.97. What is the ratio of the Expenses (in $) in Norway in 2008 to that in 2010?
Give a very brief answer. 0.88. What is the ratio of the Expenses (in $) in United States in 2008 to that in 2010?
Provide a succinct answer. 0.86. What is the ratio of the Expenses (in $) of France in 2009 to that in 2010?
Provide a succinct answer. 0.92. What is the ratio of the Expenses (in $) in Mongolia in 2009 to that in 2010?
Provide a succinct answer. 0.76. What is the ratio of the Expenses (in $) in Norway in 2009 to that in 2010?
Give a very brief answer. 0.97. What is the ratio of the Expenses (in $) of United States in 2009 to that in 2010?
Provide a short and direct response. 0.91. What is the difference between the highest and the second highest Expenses (in $) in France?
Offer a terse response. 5.20e+09. What is the difference between the highest and the second highest Expenses (in $) in Mongolia?
Ensure brevity in your answer.  1.36e+1. What is the difference between the highest and the second highest Expenses (in $) in Norway?
Your response must be concise. 2.29e+09. What is the difference between the highest and the second highest Expenses (in $) in United States?
Provide a succinct answer. 3.37e+1. What is the difference between the highest and the lowest Expenses (in $) in France?
Offer a terse response. 1.94e+1. What is the difference between the highest and the lowest Expenses (in $) in Mongolia?
Your response must be concise. 3.63e+11. What is the difference between the highest and the lowest Expenses (in $) of Norway?
Provide a succinct answer. 3.60e+1. What is the difference between the highest and the lowest Expenses (in $) of United States?
Provide a succinct answer. 2.32e+11. 